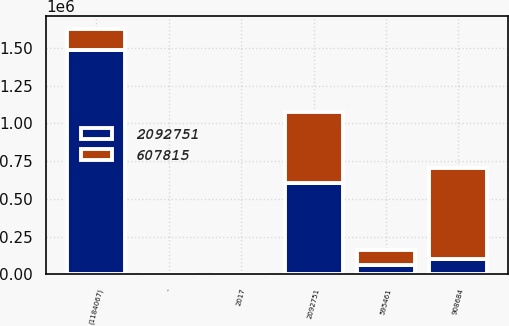Convert chart. <chart><loc_0><loc_0><loc_500><loc_500><stacked_bar_chart><ecel><fcel>2017<fcel>-<fcel>595461<fcel>(1184067)<fcel>2092751<fcel>908684<nl><fcel>2.09275e+06<fcel>2016<fcel>758<fcel>59944<fcel>1.48494e+06<fcel>607815<fcel>98548<nl><fcel>607815<fcel>2015<fcel>1216<fcel>98548<fcel>141212<fcel>466603<fcel>607815<nl></chart> 